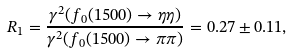Convert formula to latex. <formula><loc_0><loc_0><loc_500><loc_500>R _ { 1 } = \frac { \gamma ^ { 2 } ( f _ { 0 } ( 1 5 0 0 ) \rightarrow \eta \eta ) } { \gamma ^ { 2 } ( f _ { 0 } ( 1 5 0 0 ) \rightarrow \pi \pi ) } = 0 . 2 7 \pm 0 . 1 1 ,</formula> 